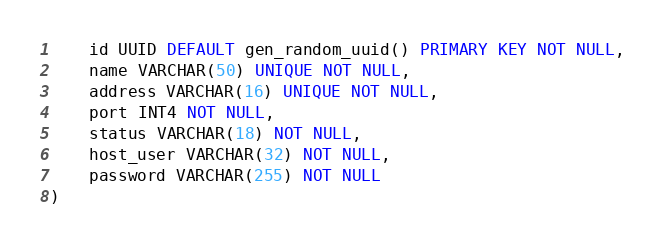<code> <loc_0><loc_0><loc_500><loc_500><_SQL_>    id UUID DEFAULT gen_random_uuid() PRIMARY KEY NOT NULL,
    name VARCHAR(50) UNIQUE NOT NULL,
    address VARCHAR(16) UNIQUE NOT NULL,
    port INT4 NOT NULL,
	status VARCHAR(18) NOT NULL,
    host_user VARCHAR(32) NOT NULL,
    password VARCHAR(255) NOT NULL
)
</code> 